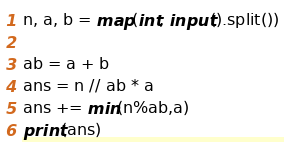<code> <loc_0><loc_0><loc_500><loc_500><_Python_>
n, a, b = map(int, input().split())

ab = a + b
ans = n // ab * a
ans += min(n%ab,a)
print(ans)</code> 